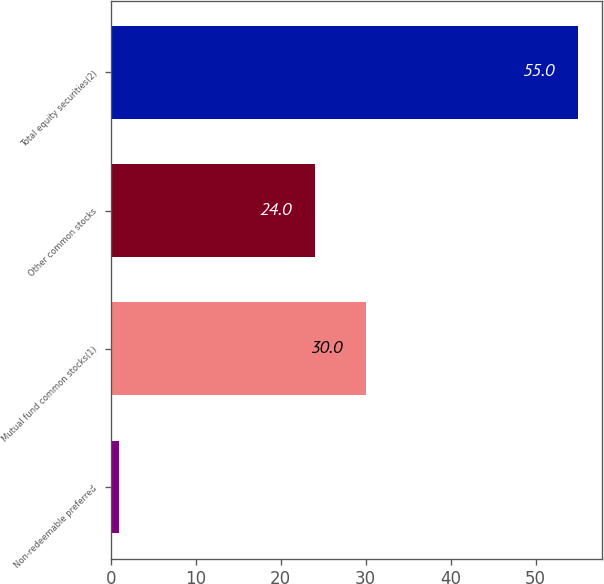Convert chart to OTSL. <chart><loc_0><loc_0><loc_500><loc_500><bar_chart><fcel>Non-redeemable preferred<fcel>Mutual fund common stocks(1)<fcel>Other common stocks<fcel>Total equity securities(2)<nl><fcel>1<fcel>30<fcel>24<fcel>55<nl></chart> 